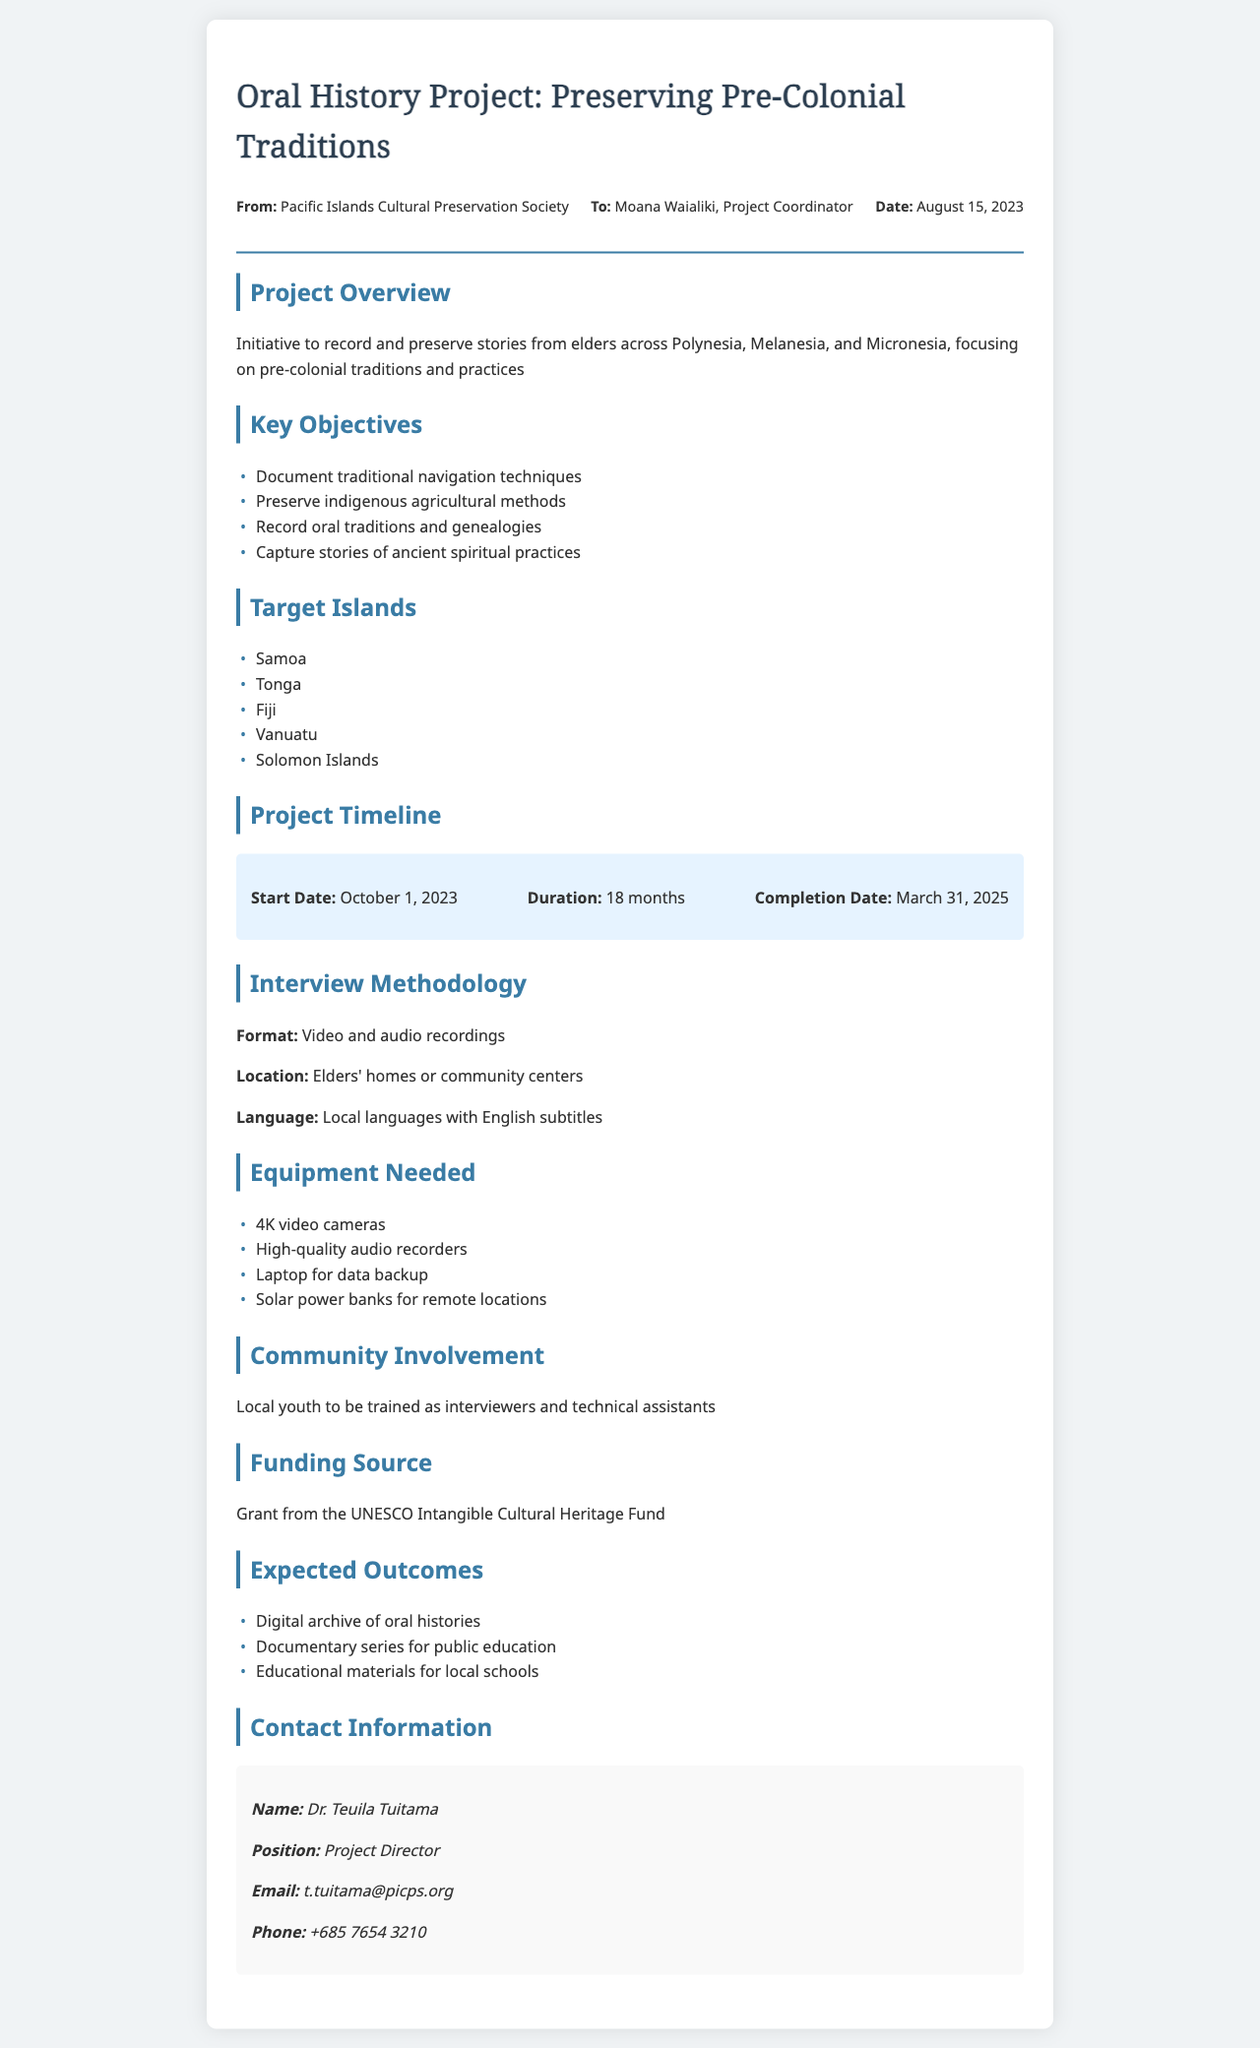What is the title of the project? The title of the project is mentioned at the top of the document and focuses on preserving oral history.
Answer: Oral History Project: Preserving Pre-Colonial Traditions Who is the project coordinator? The project coordinator's name is provided in the document under the recipient section.
Answer: Moana Waialiki What is the funding source? The document specifies the financial support received for the project.
Answer: Grant from the UNESCO Intangible Cultural Heritage Fund How long is the project duration? The duration is stated clearly in the timeline section, indicating how long the project will last.
Answer: 18 months What equipment is needed for the project? The list of equipment is provided, highlighting necessary items for conducting interviews.
Answer: 4K video cameras Name one key objective of the project. The document lists several objectives under the key objectives section and requires recalling one.
Answer: Document traditional navigation techniques What is the start date of the project? The start date is included in the timeline section of the document.
Answer: October 1, 2023 Which islands are targeted for this project? The document outlines specific islands in the project, asking to name one or more.
Answer: Samoa, Tonga, Fiji, Vanuatu, Solomon Islands What type of recordings will be used for interviews? The format of the recordings for capturing the stories is mentioned in the interview methodology section.
Answer: Video and audio recordings 